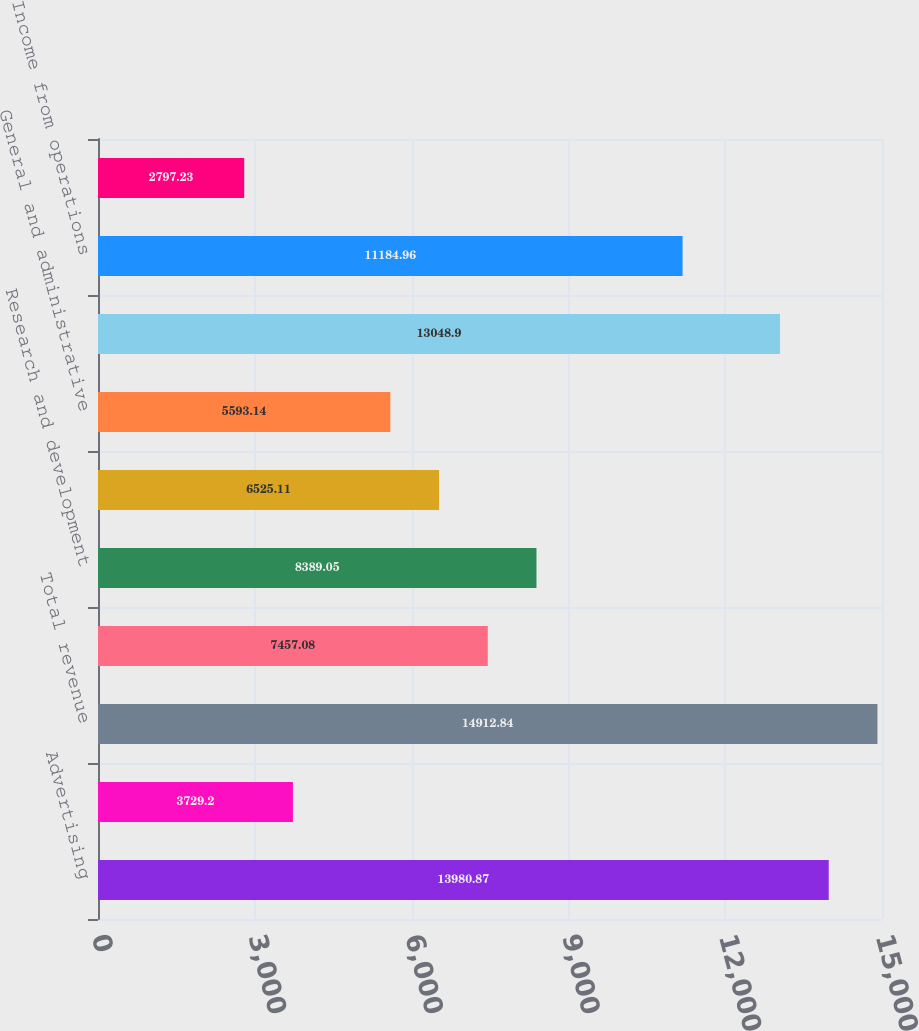Convert chart to OTSL. <chart><loc_0><loc_0><loc_500><loc_500><bar_chart><fcel>Advertising<fcel>Payments and other fees<fcel>Total revenue<fcel>Cost of revenue<fcel>Research and development<fcel>Marketing and sales<fcel>General and administrative<fcel>Total costs and expenses<fcel>Income from operations<fcel>Interest and other income<nl><fcel>13980.9<fcel>3729.2<fcel>14912.8<fcel>7457.08<fcel>8389.05<fcel>6525.11<fcel>5593.14<fcel>13048.9<fcel>11185<fcel>2797.23<nl></chart> 